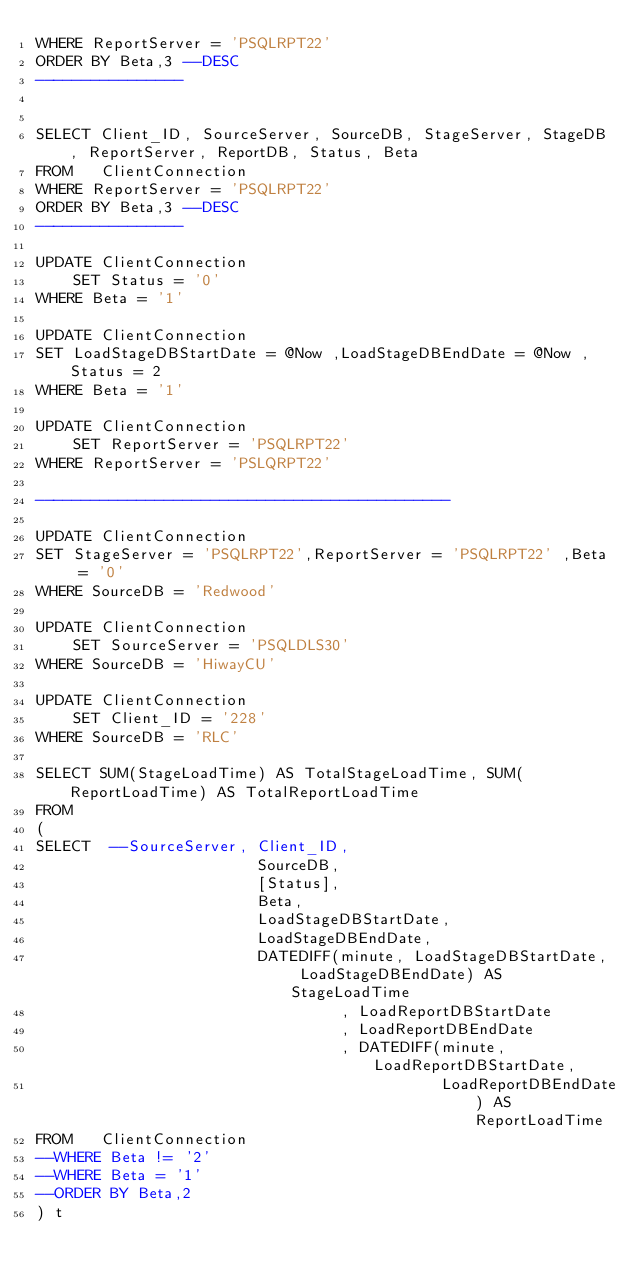Convert code to text. <code><loc_0><loc_0><loc_500><loc_500><_SQL_>WHERE ReportServer = 'PSQLRPT22'
ORDER BY Beta,3 --DESC
----------------


SELECT Client_ID, SourceServer, SourceDB, StageServer, StageDB, ReportServer, ReportDB, Status, Beta
FROM   ClientConnection
WHERE ReportServer = 'PSQLRPT22'
ORDER BY Beta,3 --DESC
----------------

UPDATE ClientConnection
    SET Status = '0'
WHERE Beta = '1'

UPDATE ClientConnection
SET LoadStageDBStartDate = @Now ,LoadStageDBEndDate = @Now ,Status = 2
WHERE Beta = '1'

UPDATE ClientConnection
    SET ReportServer = 'PSQLRPT22'
WHERE ReportServer = 'PSLQRPT22'

---------------------------------------------

UPDATE ClientConnection
SET StageServer = 'PSQLRPT22',ReportServer = 'PSQLRPT22' ,Beta = '0'
WHERE SourceDB = 'Redwood'

UPDATE ClientConnection
    SET SourceServer = 'PSQLDLS30'
WHERE SourceDB = 'HiwayCU'

UPDATE ClientConnection
    SET Client_ID = '228'
WHERE SourceDB = 'RLC'

SELECT SUM(StageLoadTime) AS TotalStageLoadTime, SUM(ReportLoadTime) AS TotalReportLoadTime
FROM
(
SELECT  --SourceServer, Client_ID,
                        SourceDB,
                        [Status],
                        Beta,
                        LoadStageDBStartDate,
                        LoadStageDBEndDate,
                        DATEDIFF(minute, LoadStageDBStartDate, LoadStageDBEndDate) AS StageLoadTime
                                 , LoadReportDBStartDate
                                 , LoadReportDBEndDate
                                 , DATEDIFF(minute, LoadReportDBStartDate,
                                            LoadReportDBEndDate) AS ReportLoadTime
FROM   ClientConnection
--WHERE Beta != '2'
--WHERE Beta = '1'
--ORDER BY Beta,2
) t</code> 